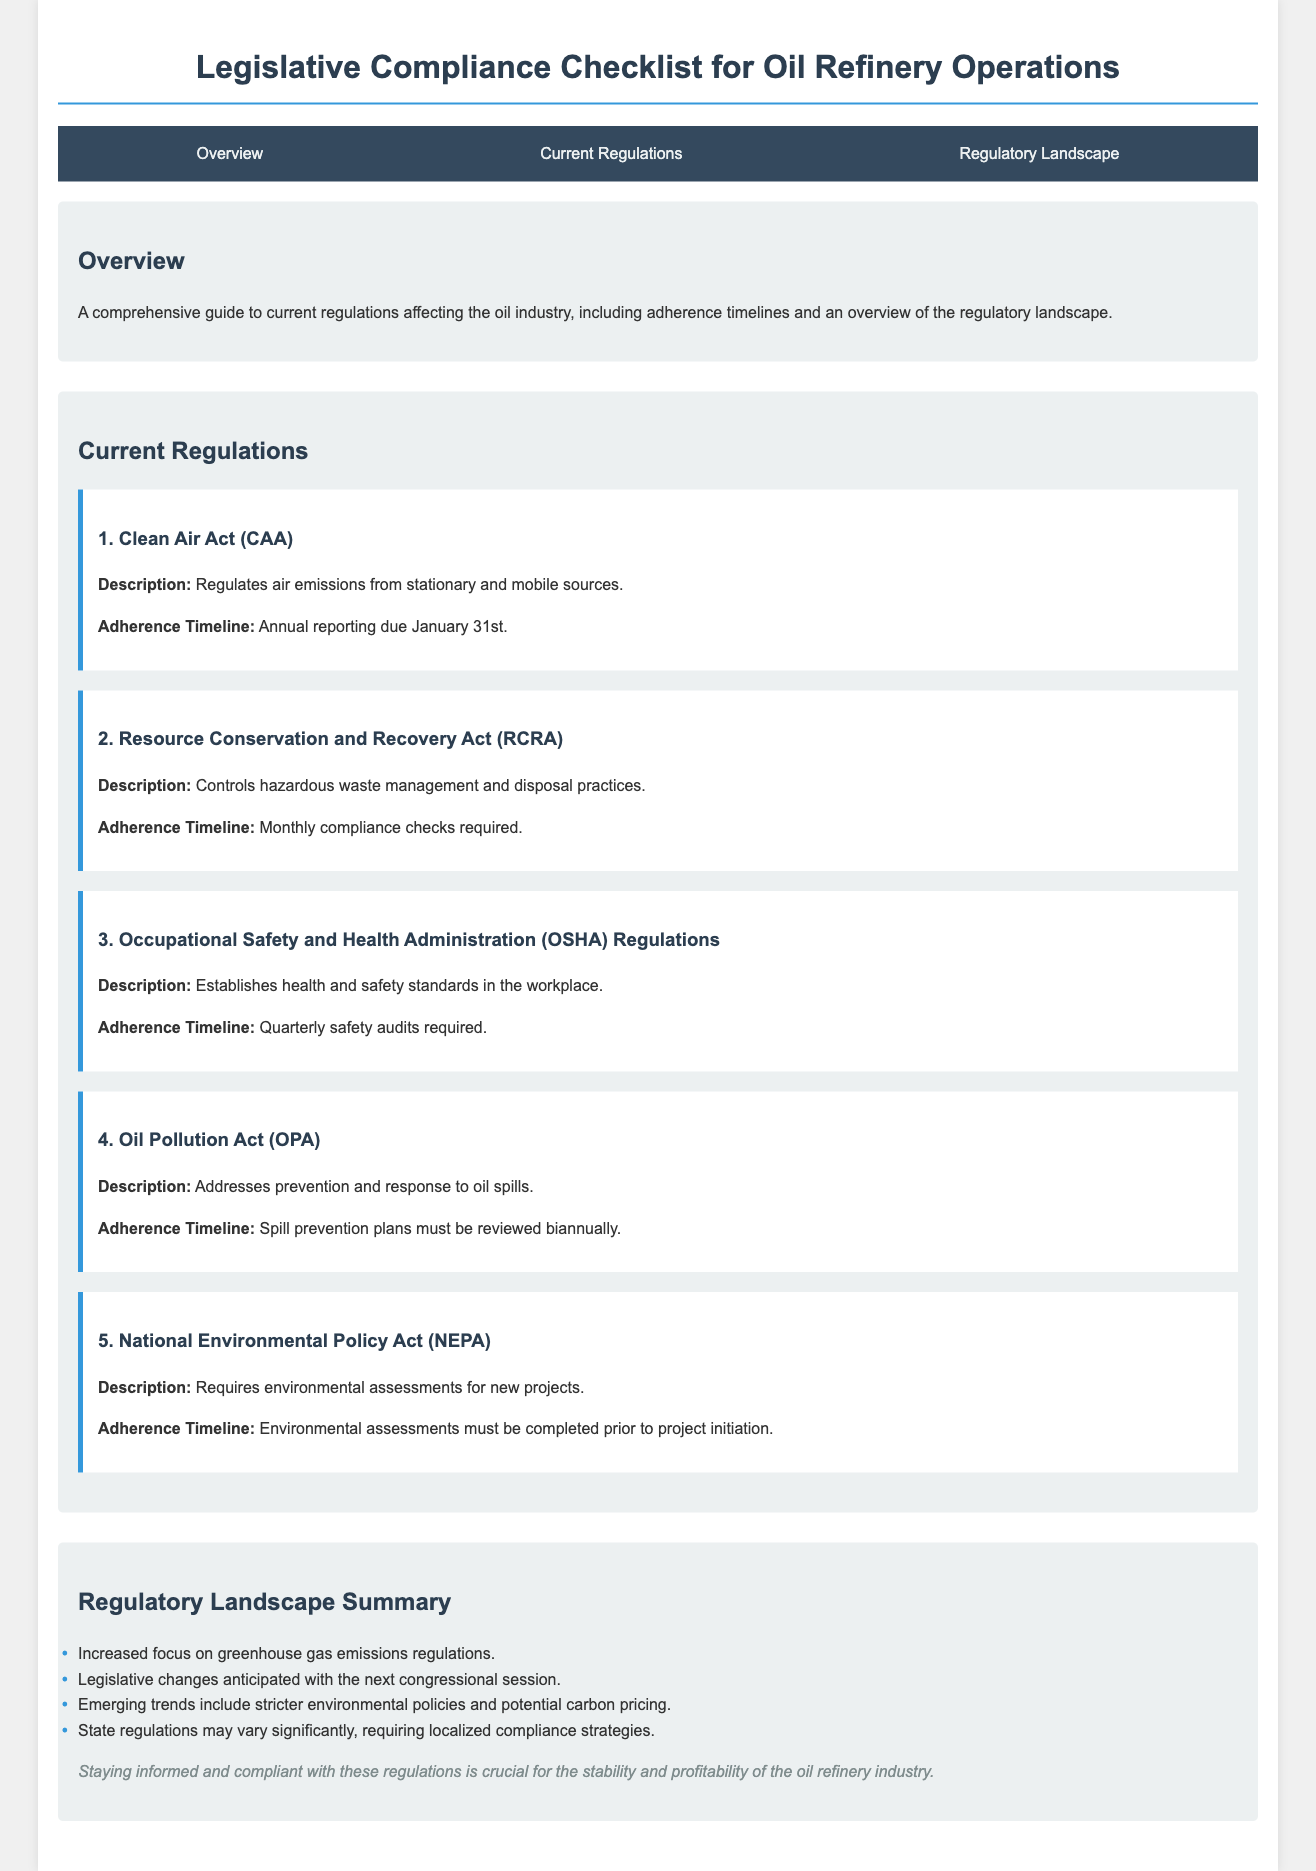What is the adherence timeline for the Clean Air Act? The adherence timeline is annual reporting due January 31st.
Answer: Annual reporting due January 31st What is the focus of the Resource Conservation and Recovery Act? It focuses on hazardous waste management and disposal practices.
Answer: Hazardous waste management How often must OSHA safety audits be conducted? The document states that OSHA audits are required quarterly.
Answer: Quarterly What must be reviewed biannually according to the Oil Pollution Act? Spill prevention plans must be reviewed biannually.
Answer: Spill prevention plans What type of assessments are required by the National Environmental Policy Act? Environmental assessments for new projects are required.
Answer: Environmental assessments What emerging trends are noted in the regulatory landscape summary? Stricter environmental policies and potential carbon pricing are noted.
Answer: Stricter environmental policies and potential carbon pricing What is essential for the stability of the oil refinery industry according to the document? Staying informed and compliant with regulations is crucial.
Answer: Staying informed and compliant How many regulations are listed under Current Regulations? There are five regulations listed under Current Regulations.
Answer: Five 